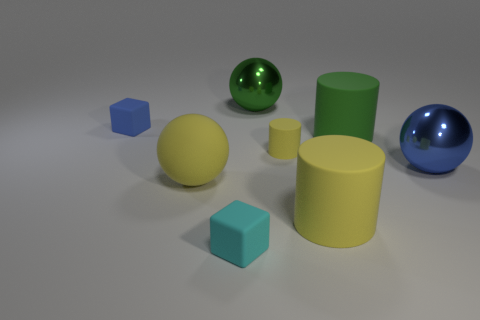What number of other yellow matte objects have the same shape as the small yellow object?
Your response must be concise. 1. There is a metal sphere behind the blue object that is on the left side of the big blue thing; what color is it?
Your response must be concise. Green. Is the number of large rubber balls that are behind the large green matte cylinder the same as the number of tiny brown cylinders?
Offer a very short reply. Yes. Are there any yellow rubber things of the same size as the green metallic sphere?
Your response must be concise. Yes. Is the size of the matte ball the same as the metal thing on the right side of the green matte object?
Give a very brief answer. Yes. Is the number of large yellow balls right of the big green rubber cylinder the same as the number of green balls behind the large yellow sphere?
Your answer should be very brief. No. There is a small thing that is the same color as the large rubber ball; what shape is it?
Offer a terse response. Cylinder. There is a blue thing that is in front of the small blue thing; what material is it?
Offer a very short reply. Metal. Does the cyan rubber cube have the same size as the green matte cylinder?
Keep it short and to the point. No. Are there more large green cylinders to the right of the big blue shiny thing than green matte things?
Your answer should be very brief. No. 